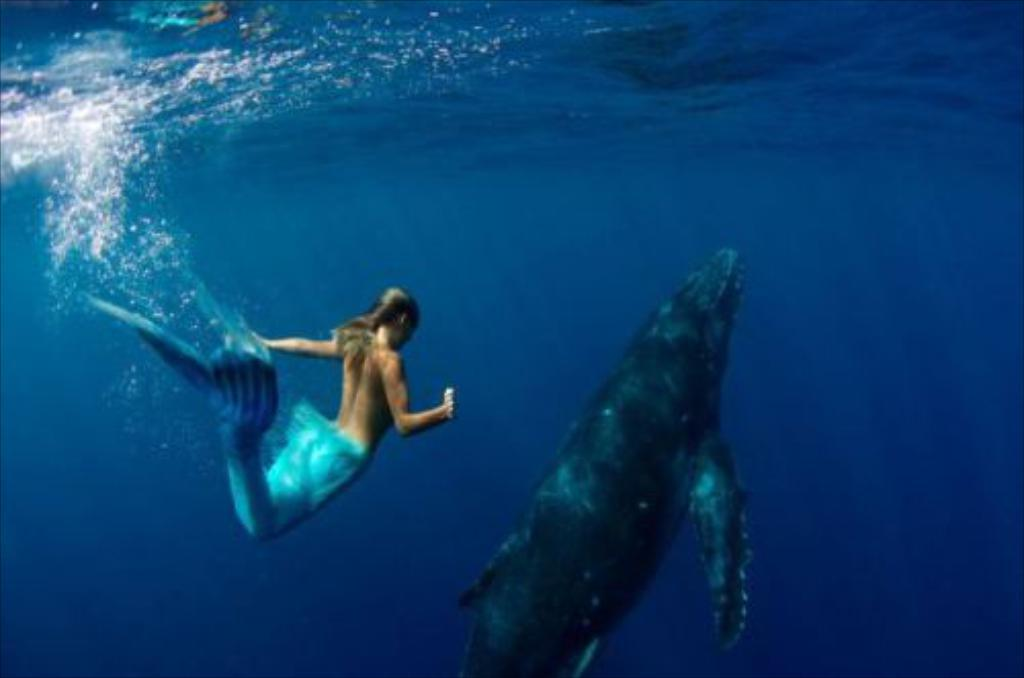What is the primary element in the image? There is water in the image. What type of animal can be seen in the water? There is a fish in the water. What mythical creature is also present in the water? There is a mermaid in the water. What type of cork can be seen floating near the mermaid in the image? There is no cork present in the image. How does the mermaid react to the zipper she finds at the bottom of the sea? There is no zipper present in the image, so the mermaid's reaction cannot be determined. 